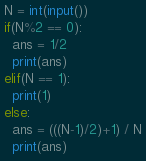Convert code to text. <code><loc_0><loc_0><loc_500><loc_500><_Python_>N = int(input())
if(N%2 == 0):
  ans = 1/2
  print(ans)
elif(N == 1):
  print(1)
else:
  ans = (((N-1)/2)+1) / N
  print(ans)</code> 